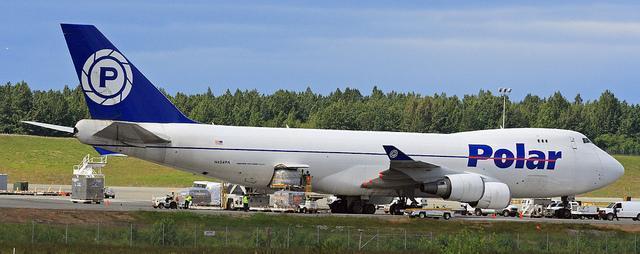How many of the benches on the boat have chains attached to them?
Give a very brief answer. 0. 